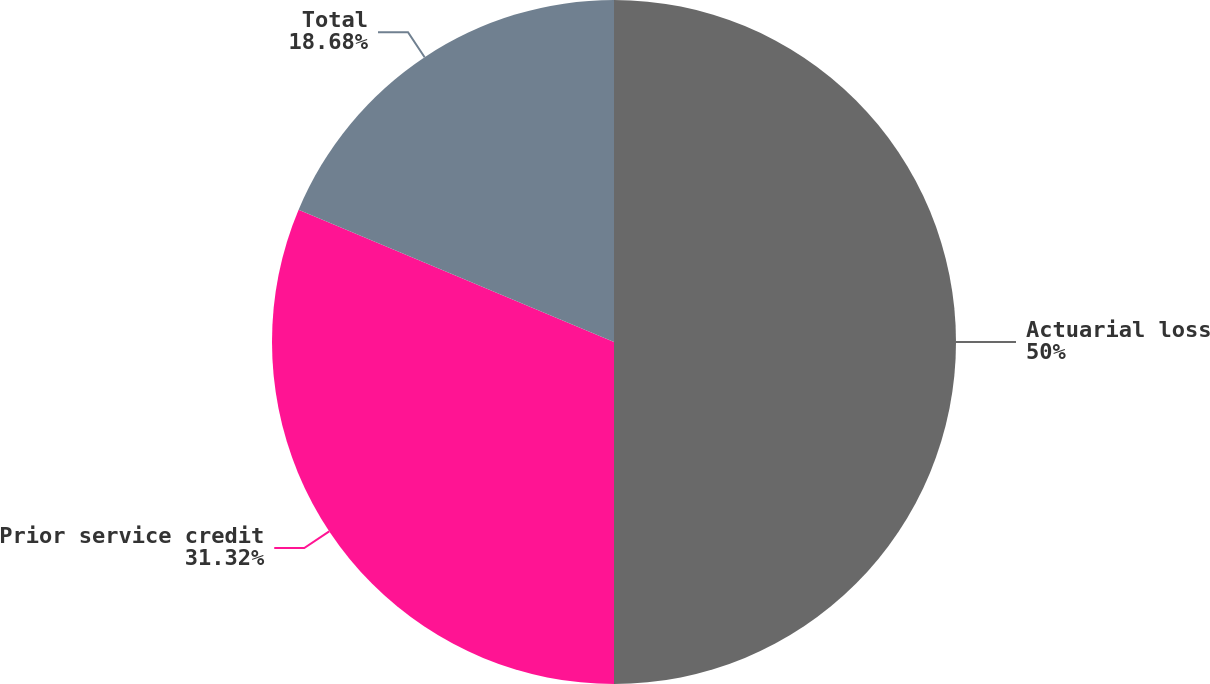Convert chart to OTSL. <chart><loc_0><loc_0><loc_500><loc_500><pie_chart><fcel>Actuarial loss<fcel>Prior service credit<fcel>Total<nl><fcel>50.0%<fcel>31.32%<fcel>18.68%<nl></chart> 